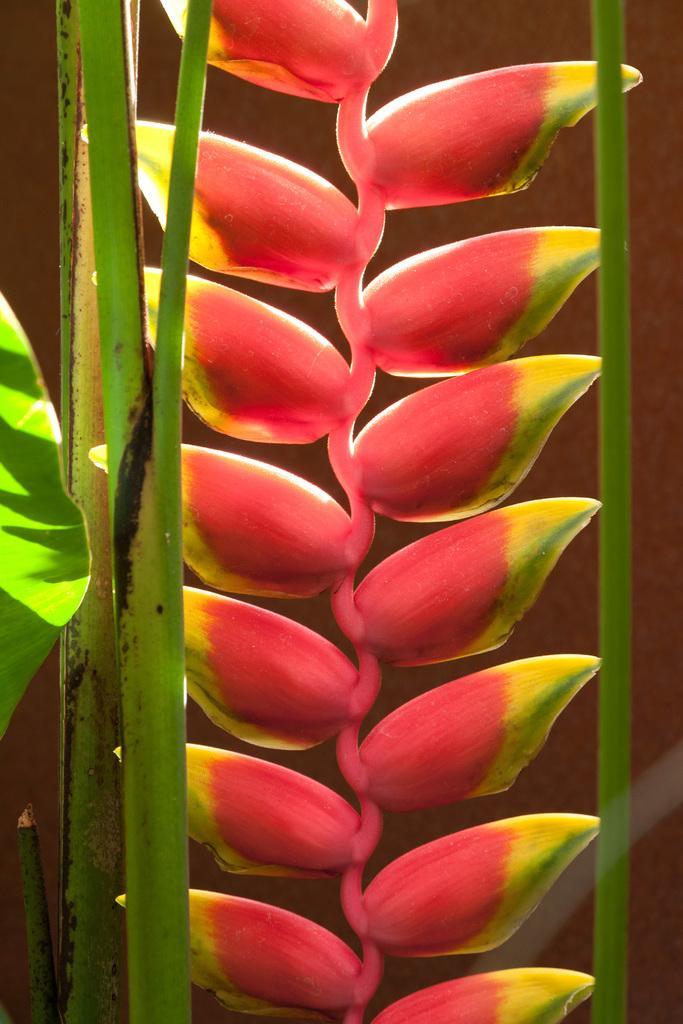Please provide a concise description of this image. This is a lobster claw plant. 